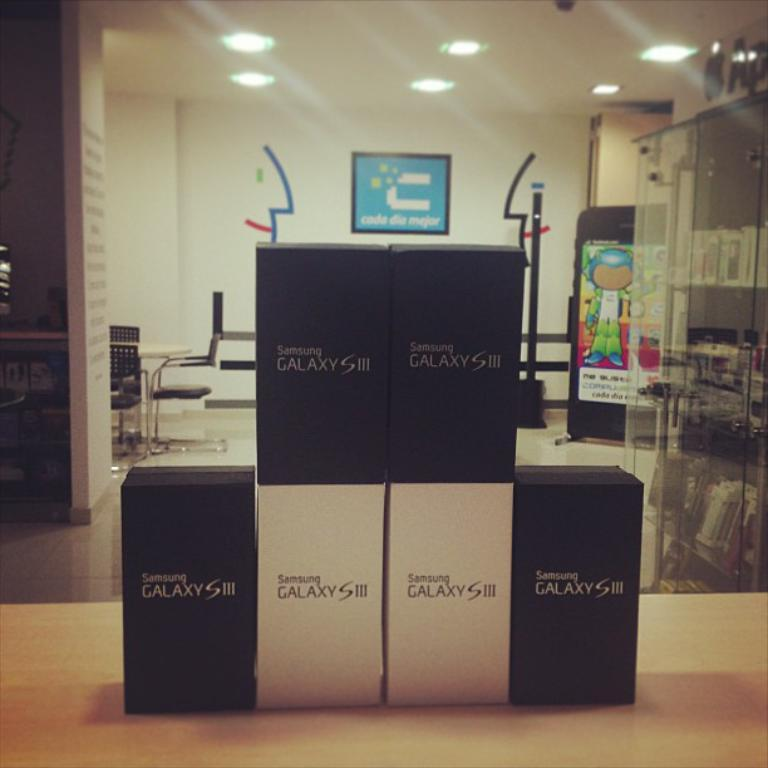<image>
Render a clear and concise summary of the photo. A stack of Samsung Galaxy S III phones on display at a mobile store. 